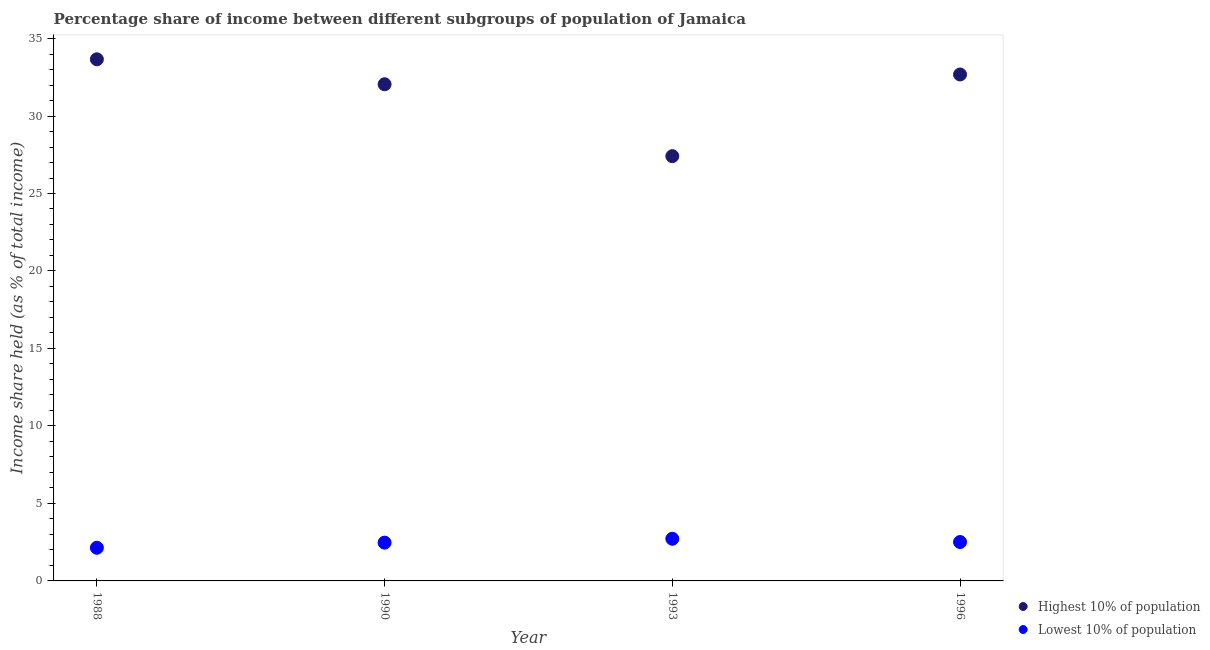How many different coloured dotlines are there?
Offer a very short reply. 2. Is the number of dotlines equal to the number of legend labels?
Make the answer very short. Yes. What is the income share held by lowest 10% of the population in 1996?
Offer a very short reply. 2.51. Across all years, what is the maximum income share held by lowest 10% of the population?
Make the answer very short. 2.72. Across all years, what is the minimum income share held by highest 10% of the population?
Offer a terse response. 27.41. In which year was the income share held by lowest 10% of the population maximum?
Offer a terse response. 1993. In which year was the income share held by lowest 10% of the population minimum?
Make the answer very short. 1988. What is the total income share held by highest 10% of the population in the graph?
Provide a short and direct response. 125.8. What is the difference between the income share held by highest 10% of the population in 1988 and that in 1993?
Your answer should be very brief. 6.25. What is the difference between the income share held by lowest 10% of the population in 1990 and the income share held by highest 10% of the population in 1988?
Give a very brief answer. -31.19. What is the average income share held by highest 10% of the population per year?
Provide a short and direct response. 31.45. In the year 1996, what is the difference between the income share held by highest 10% of the population and income share held by lowest 10% of the population?
Ensure brevity in your answer.  30.17. What is the ratio of the income share held by lowest 10% of the population in 1993 to that in 1996?
Make the answer very short. 1.08. Is the income share held by highest 10% of the population in 1988 less than that in 1990?
Your answer should be very brief. No. Is the difference between the income share held by lowest 10% of the population in 1988 and 1990 greater than the difference between the income share held by highest 10% of the population in 1988 and 1990?
Give a very brief answer. No. What is the difference between the highest and the second highest income share held by highest 10% of the population?
Make the answer very short. 0.98. What is the difference between the highest and the lowest income share held by lowest 10% of the population?
Provide a short and direct response. 0.58. Is the sum of the income share held by highest 10% of the population in 1990 and 1993 greater than the maximum income share held by lowest 10% of the population across all years?
Your answer should be compact. Yes. Is the income share held by lowest 10% of the population strictly greater than the income share held by highest 10% of the population over the years?
Your answer should be very brief. No. How many dotlines are there?
Your answer should be very brief. 2. How many years are there in the graph?
Keep it short and to the point. 4. Are the values on the major ticks of Y-axis written in scientific E-notation?
Ensure brevity in your answer.  No. Where does the legend appear in the graph?
Offer a very short reply. Bottom right. What is the title of the graph?
Ensure brevity in your answer.  Percentage share of income between different subgroups of population of Jamaica. Does "Start a business" appear as one of the legend labels in the graph?
Your answer should be very brief. No. What is the label or title of the Y-axis?
Make the answer very short. Income share held (as % of total income). What is the Income share held (as % of total income) in Highest 10% of population in 1988?
Keep it short and to the point. 33.66. What is the Income share held (as % of total income) of Lowest 10% of population in 1988?
Keep it short and to the point. 2.14. What is the Income share held (as % of total income) in Highest 10% of population in 1990?
Give a very brief answer. 32.05. What is the Income share held (as % of total income) of Lowest 10% of population in 1990?
Provide a short and direct response. 2.47. What is the Income share held (as % of total income) in Highest 10% of population in 1993?
Provide a succinct answer. 27.41. What is the Income share held (as % of total income) of Lowest 10% of population in 1993?
Keep it short and to the point. 2.72. What is the Income share held (as % of total income) of Highest 10% of population in 1996?
Ensure brevity in your answer.  32.68. What is the Income share held (as % of total income) in Lowest 10% of population in 1996?
Give a very brief answer. 2.51. Across all years, what is the maximum Income share held (as % of total income) of Highest 10% of population?
Keep it short and to the point. 33.66. Across all years, what is the maximum Income share held (as % of total income) in Lowest 10% of population?
Give a very brief answer. 2.72. Across all years, what is the minimum Income share held (as % of total income) of Highest 10% of population?
Provide a succinct answer. 27.41. Across all years, what is the minimum Income share held (as % of total income) in Lowest 10% of population?
Ensure brevity in your answer.  2.14. What is the total Income share held (as % of total income) of Highest 10% of population in the graph?
Your answer should be compact. 125.8. What is the total Income share held (as % of total income) in Lowest 10% of population in the graph?
Keep it short and to the point. 9.84. What is the difference between the Income share held (as % of total income) in Highest 10% of population in 1988 and that in 1990?
Offer a very short reply. 1.61. What is the difference between the Income share held (as % of total income) in Lowest 10% of population in 1988 and that in 1990?
Ensure brevity in your answer.  -0.33. What is the difference between the Income share held (as % of total income) of Highest 10% of population in 1988 and that in 1993?
Ensure brevity in your answer.  6.25. What is the difference between the Income share held (as % of total income) of Lowest 10% of population in 1988 and that in 1993?
Offer a very short reply. -0.58. What is the difference between the Income share held (as % of total income) of Highest 10% of population in 1988 and that in 1996?
Make the answer very short. 0.98. What is the difference between the Income share held (as % of total income) of Lowest 10% of population in 1988 and that in 1996?
Provide a short and direct response. -0.37. What is the difference between the Income share held (as % of total income) in Highest 10% of population in 1990 and that in 1993?
Your answer should be compact. 4.64. What is the difference between the Income share held (as % of total income) of Lowest 10% of population in 1990 and that in 1993?
Make the answer very short. -0.25. What is the difference between the Income share held (as % of total income) in Highest 10% of population in 1990 and that in 1996?
Offer a very short reply. -0.63. What is the difference between the Income share held (as % of total income) of Lowest 10% of population in 1990 and that in 1996?
Ensure brevity in your answer.  -0.04. What is the difference between the Income share held (as % of total income) of Highest 10% of population in 1993 and that in 1996?
Keep it short and to the point. -5.27. What is the difference between the Income share held (as % of total income) in Lowest 10% of population in 1993 and that in 1996?
Your answer should be compact. 0.21. What is the difference between the Income share held (as % of total income) of Highest 10% of population in 1988 and the Income share held (as % of total income) of Lowest 10% of population in 1990?
Your answer should be compact. 31.19. What is the difference between the Income share held (as % of total income) of Highest 10% of population in 1988 and the Income share held (as % of total income) of Lowest 10% of population in 1993?
Provide a succinct answer. 30.94. What is the difference between the Income share held (as % of total income) in Highest 10% of population in 1988 and the Income share held (as % of total income) in Lowest 10% of population in 1996?
Offer a terse response. 31.15. What is the difference between the Income share held (as % of total income) in Highest 10% of population in 1990 and the Income share held (as % of total income) in Lowest 10% of population in 1993?
Your answer should be very brief. 29.33. What is the difference between the Income share held (as % of total income) of Highest 10% of population in 1990 and the Income share held (as % of total income) of Lowest 10% of population in 1996?
Ensure brevity in your answer.  29.54. What is the difference between the Income share held (as % of total income) in Highest 10% of population in 1993 and the Income share held (as % of total income) in Lowest 10% of population in 1996?
Ensure brevity in your answer.  24.9. What is the average Income share held (as % of total income) in Highest 10% of population per year?
Provide a succinct answer. 31.45. What is the average Income share held (as % of total income) in Lowest 10% of population per year?
Offer a terse response. 2.46. In the year 1988, what is the difference between the Income share held (as % of total income) of Highest 10% of population and Income share held (as % of total income) of Lowest 10% of population?
Your answer should be compact. 31.52. In the year 1990, what is the difference between the Income share held (as % of total income) in Highest 10% of population and Income share held (as % of total income) in Lowest 10% of population?
Give a very brief answer. 29.58. In the year 1993, what is the difference between the Income share held (as % of total income) in Highest 10% of population and Income share held (as % of total income) in Lowest 10% of population?
Your response must be concise. 24.69. In the year 1996, what is the difference between the Income share held (as % of total income) of Highest 10% of population and Income share held (as % of total income) of Lowest 10% of population?
Keep it short and to the point. 30.17. What is the ratio of the Income share held (as % of total income) of Highest 10% of population in 1988 to that in 1990?
Provide a succinct answer. 1.05. What is the ratio of the Income share held (as % of total income) in Lowest 10% of population in 1988 to that in 1990?
Offer a terse response. 0.87. What is the ratio of the Income share held (as % of total income) in Highest 10% of population in 1988 to that in 1993?
Make the answer very short. 1.23. What is the ratio of the Income share held (as % of total income) in Lowest 10% of population in 1988 to that in 1993?
Provide a succinct answer. 0.79. What is the ratio of the Income share held (as % of total income) in Lowest 10% of population in 1988 to that in 1996?
Offer a very short reply. 0.85. What is the ratio of the Income share held (as % of total income) of Highest 10% of population in 1990 to that in 1993?
Provide a short and direct response. 1.17. What is the ratio of the Income share held (as % of total income) in Lowest 10% of population in 1990 to that in 1993?
Make the answer very short. 0.91. What is the ratio of the Income share held (as % of total income) in Highest 10% of population in 1990 to that in 1996?
Provide a succinct answer. 0.98. What is the ratio of the Income share held (as % of total income) of Lowest 10% of population in 1990 to that in 1996?
Your answer should be compact. 0.98. What is the ratio of the Income share held (as % of total income) in Highest 10% of population in 1993 to that in 1996?
Offer a terse response. 0.84. What is the ratio of the Income share held (as % of total income) of Lowest 10% of population in 1993 to that in 1996?
Give a very brief answer. 1.08. What is the difference between the highest and the second highest Income share held (as % of total income) of Highest 10% of population?
Your answer should be very brief. 0.98. What is the difference between the highest and the second highest Income share held (as % of total income) in Lowest 10% of population?
Ensure brevity in your answer.  0.21. What is the difference between the highest and the lowest Income share held (as % of total income) in Highest 10% of population?
Make the answer very short. 6.25. What is the difference between the highest and the lowest Income share held (as % of total income) in Lowest 10% of population?
Your response must be concise. 0.58. 